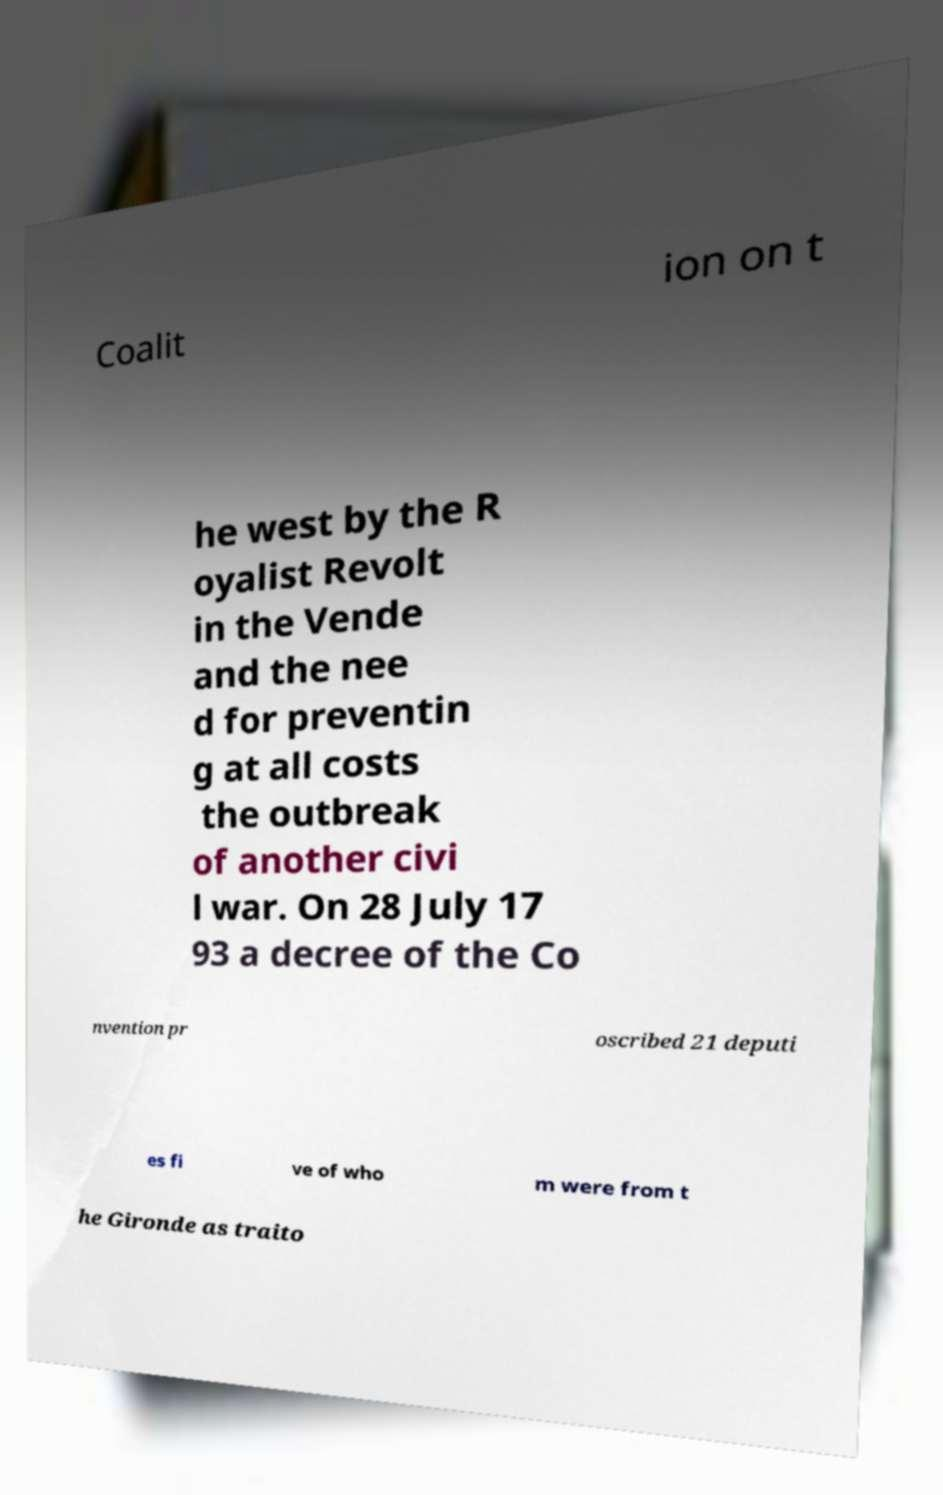Could you assist in decoding the text presented in this image and type it out clearly? Coalit ion on t he west by the R oyalist Revolt in the Vende and the nee d for preventin g at all costs the outbreak of another civi l war. On 28 July 17 93 a decree of the Co nvention pr oscribed 21 deputi es fi ve of who m were from t he Gironde as traito 